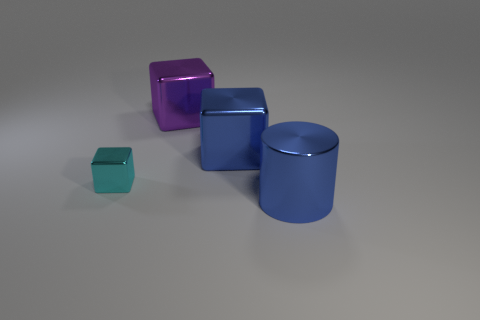There is a large shiny thing in front of the tiny shiny object; what is its color?
Offer a very short reply. Blue. What is the shape of the shiny object that is the same color as the metallic cylinder?
Your answer should be very brief. Cube. What number of other shiny blocks are the same size as the cyan shiny cube?
Give a very brief answer. 0. There is a thing that is left of the purple metallic thing; is it the same shape as the large blue metal object that is behind the cylinder?
Your answer should be compact. Yes. There is a big cube that is in front of the purple metal object behind the thing to the right of the big blue metal block; what is its material?
Offer a very short reply. Metal. There is a blue thing that is the same size as the cylinder; what shape is it?
Offer a very short reply. Cube. Are there any big objects that have the same color as the tiny metal thing?
Provide a short and direct response. No. The purple block has what size?
Make the answer very short. Large. Is the material of the blue cylinder the same as the tiny cyan block?
Offer a very short reply. Yes. There is a cyan metal cube on the left side of the blue object in front of the cyan metal block; what number of big blue metallic cylinders are behind it?
Your answer should be very brief. 0. 